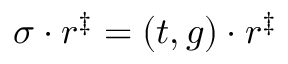Convert formula to latex. <formula><loc_0><loc_0><loc_500><loc_500>\sigma \cdot r ^ { \ddag } = \left ( t , g \right ) \cdot r ^ { \ddag }</formula> 